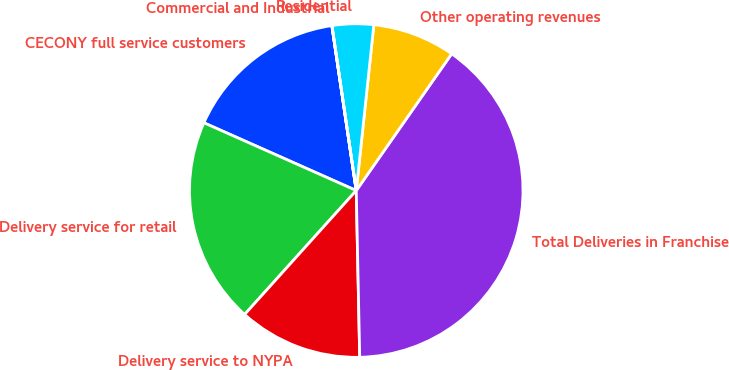Convert chart. <chart><loc_0><loc_0><loc_500><loc_500><pie_chart><fcel>CECONY full service customers<fcel>Delivery service for retail<fcel>Delivery service to NYPA<fcel>Total Deliveries in Franchise<fcel>Other operating revenues<fcel>Residential<fcel>Commercial and Industrial<nl><fcel>16.0%<fcel>19.99%<fcel>12.0%<fcel>39.97%<fcel>8.01%<fcel>4.01%<fcel>0.01%<nl></chart> 